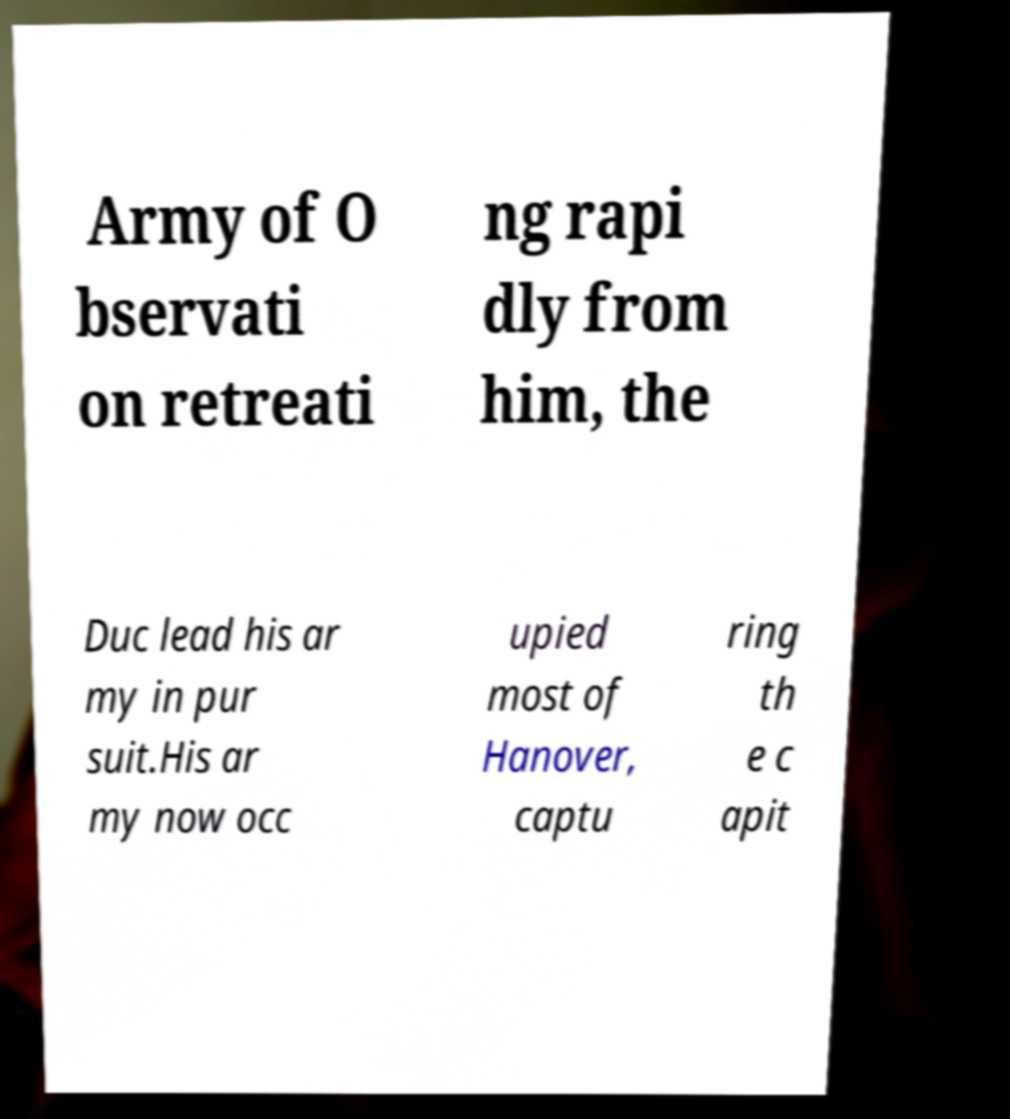Could you assist in decoding the text presented in this image and type it out clearly? Army of O bservati on retreati ng rapi dly from him, the Duc lead his ar my in pur suit.His ar my now occ upied most of Hanover, captu ring th e c apit 